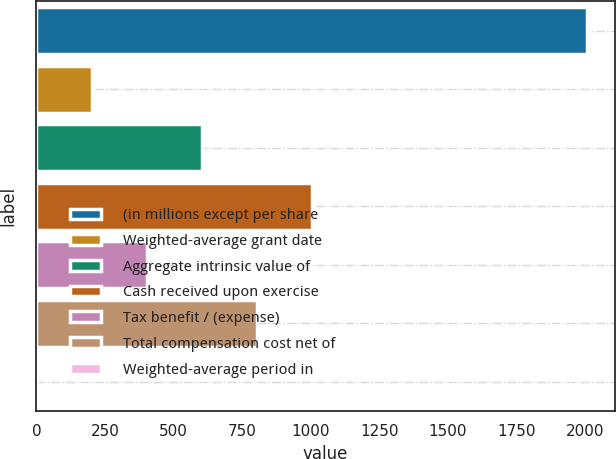Convert chart. <chart><loc_0><loc_0><loc_500><loc_500><bar_chart><fcel>(in millions except per share<fcel>Weighted-average grant date<fcel>Aggregate intrinsic value of<fcel>Cash received upon exercise<fcel>Tax benefit / (expense)<fcel>Total compensation cost net of<fcel>Weighted-average period in<nl><fcel>2008<fcel>202.51<fcel>603.73<fcel>1004.95<fcel>403.12<fcel>804.34<fcel>1.9<nl></chart> 